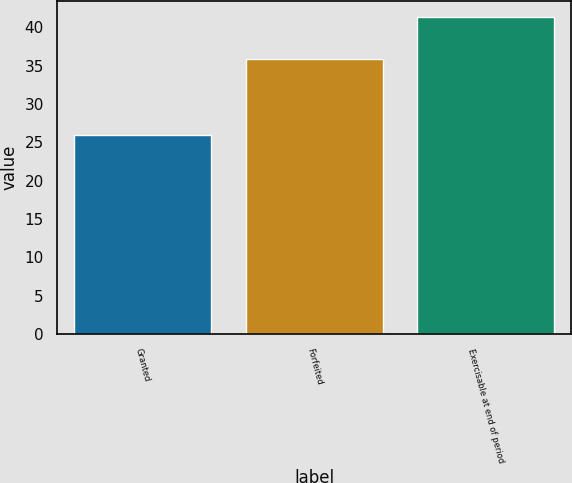<chart> <loc_0><loc_0><loc_500><loc_500><bar_chart><fcel>Granted<fcel>Forfeited<fcel>Exercisable at end of period<nl><fcel>25.95<fcel>35.84<fcel>41.36<nl></chart> 